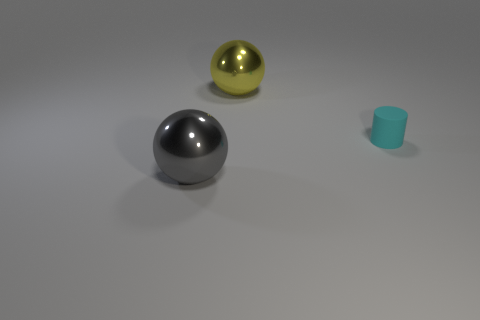Are there fewer tiny cyan rubber cylinders in front of the big gray shiny ball than small objects behind the yellow sphere?
Keep it short and to the point. No. Do the cyan object and the large thing in front of the large yellow sphere have the same material?
Give a very brief answer. No. Is there anything else that is the same material as the small object?
Provide a short and direct response. No. Is the number of gray balls greater than the number of red shiny spheres?
Provide a succinct answer. Yes. What shape is the shiny thing that is in front of the sphere on the right side of the ball in front of the small cyan matte cylinder?
Provide a succinct answer. Sphere. Does the large sphere in front of the yellow sphere have the same material as the small cylinder that is on the right side of the gray thing?
Your answer should be very brief. No. Is there anything else that is the same color as the small rubber cylinder?
Offer a terse response. No. How many gray objects are there?
Offer a very short reply. 1. What is the big object that is in front of the large ball right of the big gray sphere made of?
Ensure brevity in your answer.  Metal. What is the color of the large metallic ball in front of the metallic sphere behind the large ball that is in front of the large yellow metal ball?
Keep it short and to the point. Gray. 